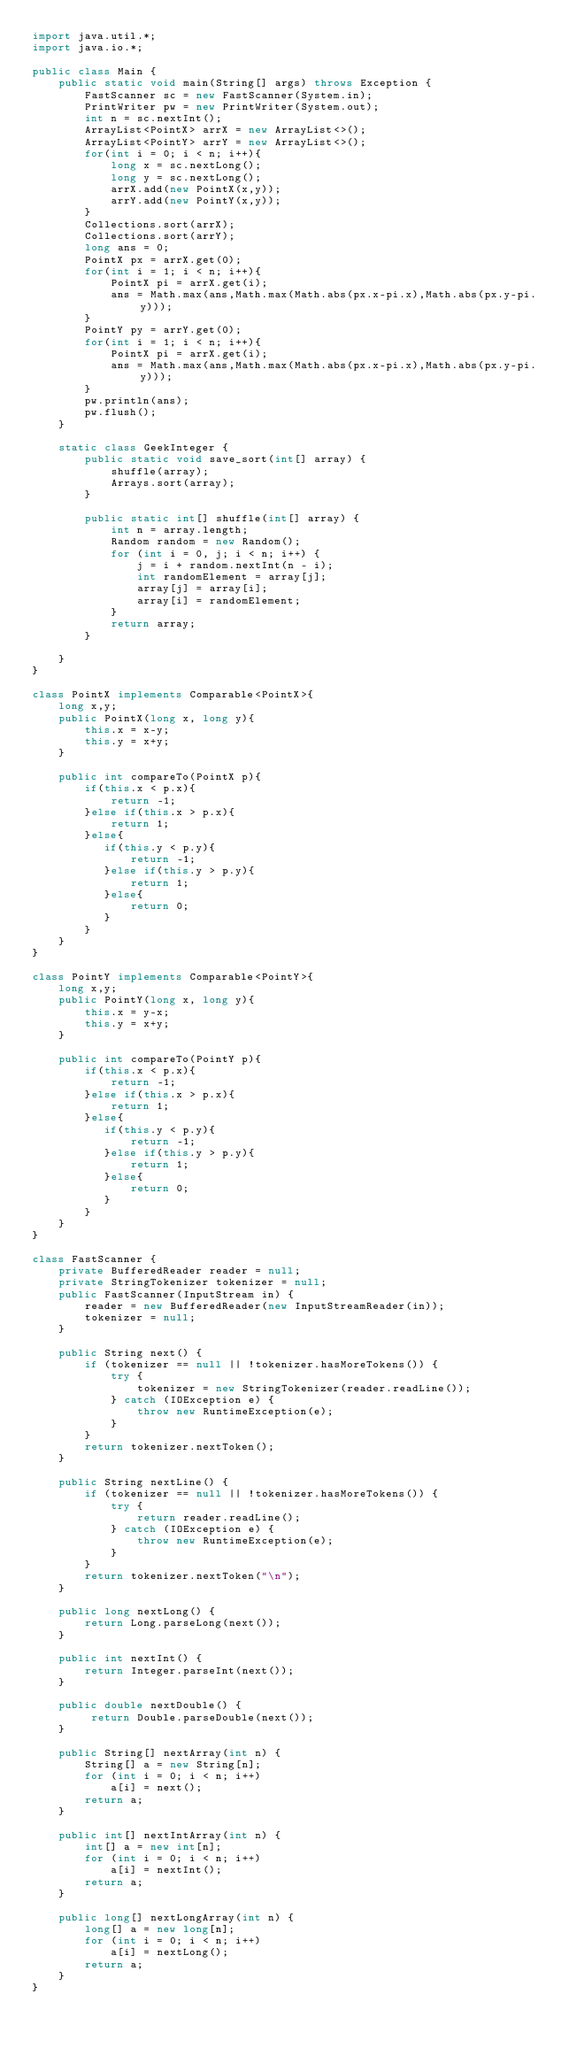Convert code to text. <code><loc_0><loc_0><loc_500><loc_500><_Java_>import java.util.*;
import java.io.*;
 
public class Main {
    public static void main(String[] args) throws Exception {
        FastScanner sc = new FastScanner(System.in);
        PrintWriter pw = new PrintWriter(System.out);
        int n = sc.nextInt();
        ArrayList<PointX> arrX = new ArrayList<>();
        ArrayList<PointY> arrY = new ArrayList<>();
        for(int i = 0; i < n; i++){
            long x = sc.nextLong();
            long y = sc.nextLong();
            arrX.add(new PointX(x,y));
            arrY.add(new PointY(x,y));
        }
        Collections.sort(arrX);
        Collections.sort(arrY);
        long ans = 0;
        PointX px = arrX.get(0);
        for(int i = 1; i < n; i++){
            PointX pi = arrX.get(i);
            ans = Math.max(ans,Math.max(Math.abs(px.x-pi.x),Math.abs(px.y-pi.y)));
        }
        PointY py = arrY.get(0);
        for(int i = 1; i < n; i++){
            PointX pi = arrX.get(i);
            ans = Math.max(ans,Math.max(Math.abs(px.x-pi.x),Math.abs(px.y-pi.y)));
        }
        pw.println(ans);
        pw.flush();
    }

    static class GeekInteger {
        public static void save_sort(int[] array) {
            shuffle(array);
            Arrays.sort(array);
        }
 
        public static int[] shuffle(int[] array) {
            int n = array.length;
            Random random = new Random();
            for (int i = 0, j; i < n; i++) {
                j = i + random.nextInt(n - i);
                int randomElement = array[j];
                array[j] = array[i];
                array[i] = randomElement;
            }
            return array;
        }
 
    }
}

class PointX implements Comparable<PointX>{
    long x,y;
    public PointX(long x, long y){
        this.x = x-y;
        this.y = x+y;
    }
    
    public int compareTo(PointX p){
        if(this.x < p.x){
            return -1;
        }else if(this.x > p.x){
            return 1;
        }else{
           if(this.y < p.y){
               return -1;
           }else if(this.y > p.y){
               return 1;
           }else{
               return 0;
           }
        }
    }
}

class PointY implements Comparable<PointY>{
    long x,y;
    public PointY(long x, long y){
        this.x = y-x;
        this.y = x+y;
    }
    
    public int compareTo(PointY p){
        if(this.x < p.x){
            return -1;
        }else if(this.x > p.x){
            return 1;
        }else{
           if(this.y < p.y){
               return -1;
           }else if(this.y > p.y){
               return 1;
           }else{
               return 0;
           }
        }
    }
}

class FastScanner {
    private BufferedReader reader = null;
    private StringTokenizer tokenizer = null;
    public FastScanner(InputStream in) {
        reader = new BufferedReader(new InputStreamReader(in));
        tokenizer = null;
    }

    public String next() {
        if (tokenizer == null || !tokenizer.hasMoreTokens()) {
            try {
                tokenizer = new StringTokenizer(reader.readLine());
            } catch (IOException e) {
                throw new RuntimeException(e);
            }
        }
        return tokenizer.nextToken();
    }

    public String nextLine() {
        if (tokenizer == null || !tokenizer.hasMoreTokens()) {
            try {
                return reader.readLine();
            } catch (IOException e) {
                throw new RuntimeException(e);
            }
        }
        return tokenizer.nextToken("\n");
    }

    public long nextLong() {
        return Long.parseLong(next());
    }

    public int nextInt() {
        return Integer.parseInt(next());
    }

    public double nextDouble() {
         return Double.parseDouble(next());
    }
    
    public String[] nextArray(int n) {
        String[] a = new String[n];
        for (int i = 0; i < n; i++)
            a[i] = next();
        return a;
    }

    public int[] nextIntArray(int n) {
        int[] a = new int[n];
        for (int i = 0; i < n; i++)
            a[i] = nextInt();
        return a;
    }

    public long[] nextLongArray(int n) {
        long[] a = new long[n];
        for (int i = 0; i < n; i++)
            a[i] = nextLong();
        return a;
    } 
}
</code> 